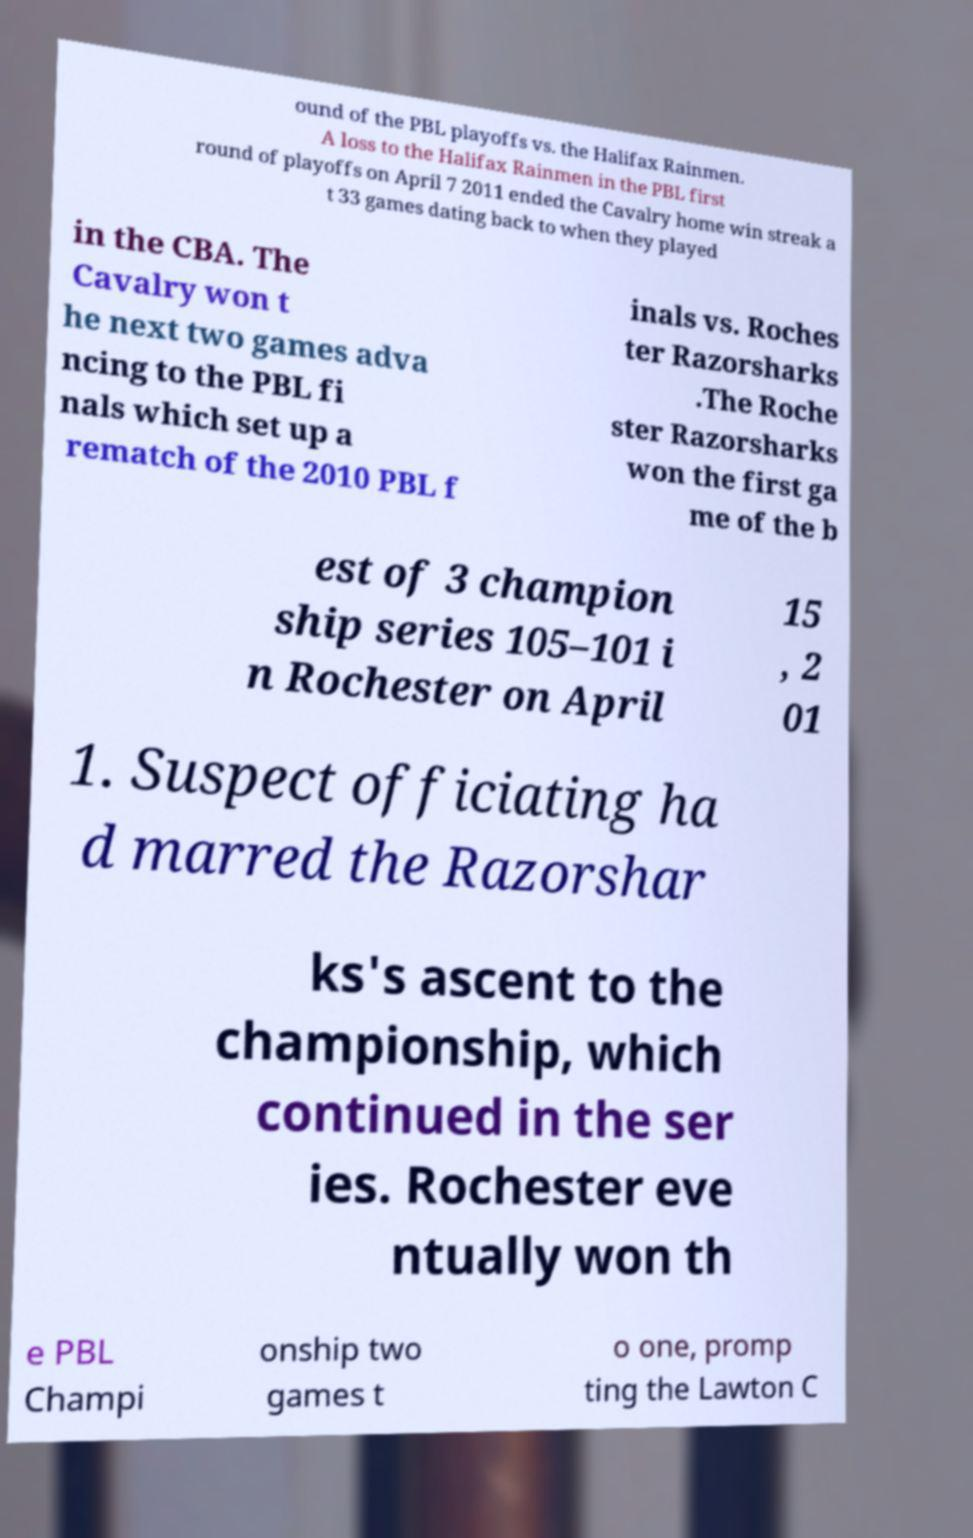What messages or text are displayed in this image? I need them in a readable, typed format. ound of the PBL playoffs vs. the Halifax Rainmen. A loss to the Halifax Rainmen in the PBL first round of playoffs on April 7 2011 ended the Cavalry home win streak a t 33 games dating back to when they played in the CBA. The Cavalry won t he next two games adva ncing to the PBL fi nals which set up a rematch of the 2010 PBL f inals vs. Roches ter Razorsharks .The Roche ster Razorsharks won the first ga me of the b est of 3 champion ship series 105–101 i n Rochester on April 15 , 2 01 1. Suspect officiating ha d marred the Razorshar ks's ascent to the championship, which continued in the ser ies. Rochester eve ntually won th e PBL Champi onship two games t o one, promp ting the Lawton C 